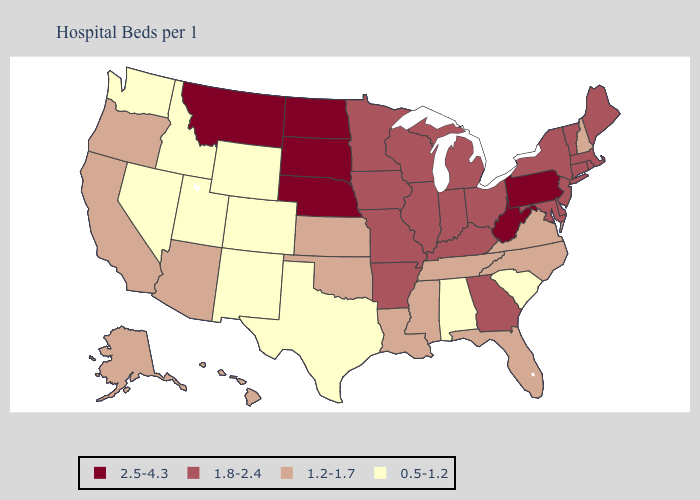What is the highest value in the South ?
Be succinct. 2.5-4.3. What is the highest value in the USA?
Quick response, please. 2.5-4.3. What is the highest value in the MidWest ?
Keep it brief. 2.5-4.3. Does Kansas have the highest value in the USA?
Concise answer only. No. Does Hawaii have a lower value than Wisconsin?
Short answer required. Yes. Which states hav the highest value in the West?
Be succinct. Montana. Name the states that have a value in the range 1.8-2.4?
Short answer required. Arkansas, Connecticut, Delaware, Georgia, Illinois, Indiana, Iowa, Kentucky, Maine, Maryland, Massachusetts, Michigan, Minnesota, Missouri, New Jersey, New York, Ohio, Rhode Island, Vermont, Wisconsin. How many symbols are there in the legend?
Be succinct. 4. Does Montana have the highest value in the USA?
Be succinct. Yes. What is the value of Mississippi?
Be succinct. 1.2-1.7. Name the states that have a value in the range 0.5-1.2?
Keep it brief. Alabama, Colorado, Idaho, Nevada, New Mexico, South Carolina, Texas, Utah, Washington, Wyoming. Is the legend a continuous bar?
Short answer required. No. Which states have the highest value in the USA?
Quick response, please. Montana, Nebraska, North Dakota, Pennsylvania, South Dakota, West Virginia. What is the lowest value in the Northeast?
Quick response, please. 1.2-1.7. Which states have the highest value in the USA?
Short answer required. Montana, Nebraska, North Dakota, Pennsylvania, South Dakota, West Virginia. 